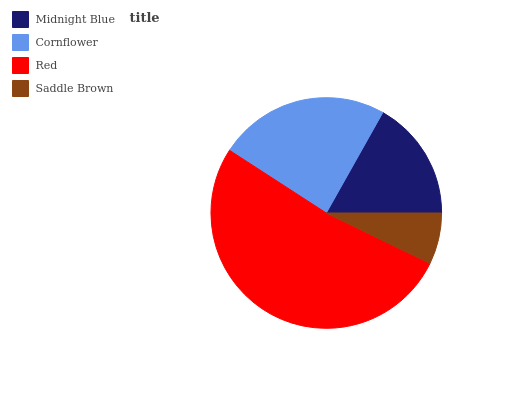Is Saddle Brown the minimum?
Answer yes or no. Yes. Is Red the maximum?
Answer yes or no. Yes. Is Cornflower the minimum?
Answer yes or no. No. Is Cornflower the maximum?
Answer yes or no. No. Is Cornflower greater than Midnight Blue?
Answer yes or no. Yes. Is Midnight Blue less than Cornflower?
Answer yes or no. Yes. Is Midnight Blue greater than Cornflower?
Answer yes or no. No. Is Cornflower less than Midnight Blue?
Answer yes or no. No. Is Cornflower the high median?
Answer yes or no. Yes. Is Midnight Blue the low median?
Answer yes or no. Yes. Is Saddle Brown the high median?
Answer yes or no. No. Is Cornflower the low median?
Answer yes or no. No. 